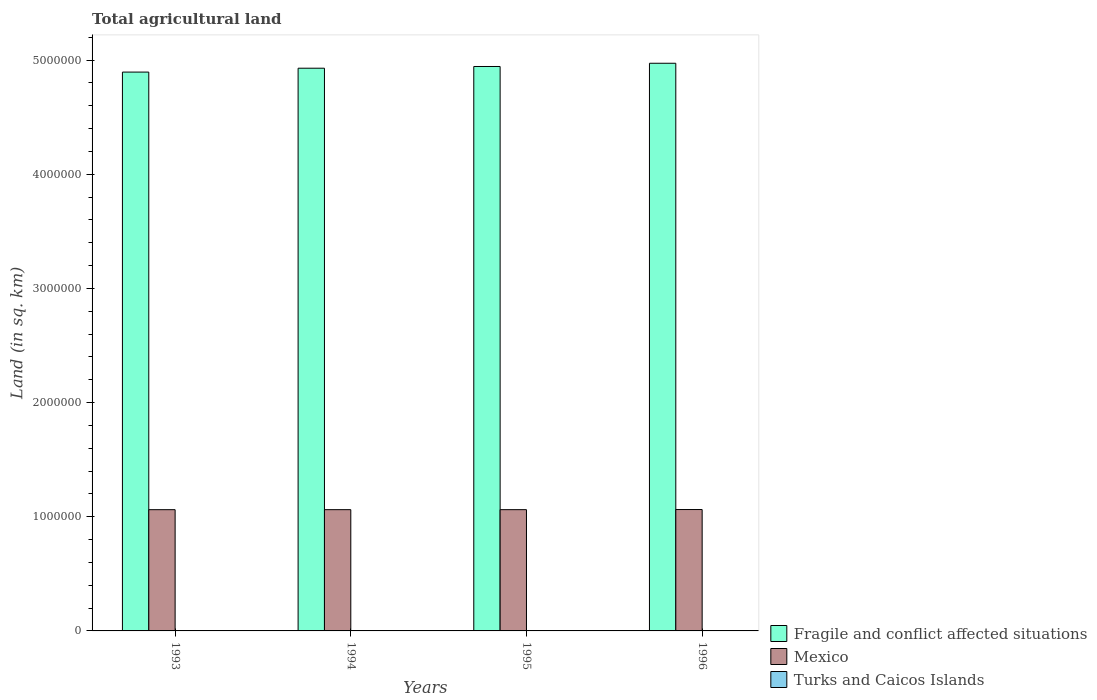How many groups of bars are there?
Make the answer very short. 4. Are the number of bars per tick equal to the number of legend labels?
Your answer should be compact. Yes. What is the label of the 2nd group of bars from the left?
Ensure brevity in your answer.  1994. What is the total agricultural land in Mexico in 1993?
Offer a very short reply. 1.06e+06. Across all years, what is the maximum total agricultural land in Turks and Caicos Islands?
Your answer should be very brief. 10. Across all years, what is the minimum total agricultural land in Mexico?
Offer a very short reply. 1.06e+06. In which year was the total agricultural land in Turks and Caicos Islands maximum?
Ensure brevity in your answer.  1993. In which year was the total agricultural land in Fragile and conflict affected situations minimum?
Your answer should be very brief. 1993. What is the total total agricultural land in Fragile and conflict affected situations in the graph?
Your answer should be compact. 1.97e+07. What is the difference between the total agricultural land in Turks and Caicos Islands in 1993 and that in 1996?
Ensure brevity in your answer.  0. What is the difference between the total agricultural land in Mexico in 1993 and the total agricultural land in Turks and Caicos Islands in 1995?
Provide a succinct answer. 1.06e+06. What is the average total agricultural land in Fragile and conflict affected situations per year?
Provide a short and direct response. 4.93e+06. In the year 1994, what is the difference between the total agricultural land in Turks and Caicos Islands and total agricultural land in Mexico?
Provide a short and direct response. -1.06e+06. In how many years, is the total agricultural land in Mexico greater than 600000 sq.km?
Your answer should be very brief. 4. What is the ratio of the total agricultural land in Mexico in 1994 to that in 1995?
Ensure brevity in your answer.  1. Is the total agricultural land in Mexico in 1993 less than that in 1994?
Give a very brief answer. Yes. What is the difference between the highest and the second highest total agricultural land in Mexico?
Provide a short and direct response. 1150. What is the difference between the highest and the lowest total agricultural land in Mexico?
Your answer should be very brief. 1300. Is the sum of the total agricultural land in Mexico in 1993 and 1996 greater than the maximum total agricultural land in Turks and Caicos Islands across all years?
Give a very brief answer. Yes. What does the 1st bar from the left in 1995 represents?
Keep it short and to the point. Fragile and conflict affected situations. What does the 3rd bar from the right in 1996 represents?
Offer a very short reply. Fragile and conflict affected situations. How many bars are there?
Offer a very short reply. 12. Are all the bars in the graph horizontal?
Your answer should be compact. No. Are the values on the major ticks of Y-axis written in scientific E-notation?
Your answer should be compact. No. Does the graph contain grids?
Make the answer very short. No. How are the legend labels stacked?
Your response must be concise. Vertical. What is the title of the graph?
Give a very brief answer. Total agricultural land. Does "Tonga" appear as one of the legend labels in the graph?
Offer a terse response. No. What is the label or title of the X-axis?
Ensure brevity in your answer.  Years. What is the label or title of the Y-axis?
Offer a very short reply. Land (in sq. km). What is the Land (in sq. km) in Fragile and conflict affected situations in 1993?
Your answer should be compact. 4.89e+06. What is the Land (in sq. km) in Mexico in 1993?
Your response must be concise. 1.06e+06. What is the Land (in sq. km) of Fragile and conflict affected situations in 1994?
Offer a terse response. 4.93e+06. What is the Land (in sq. km) in Mexico in 1994?
Make the answer very short. 1.06e+06. What is the Land (in sq. km) of Fragile and conflict affected situations in 1995?
Provide a short and direct response. 4.94e+06. What is the Land (in sq. km) in Mexico in 1995?
Keep it short and to the point. 1.06e+06. What is the Land (in sq. km) of Turks and Caicos Islands in 1995?
Offer a terse response. 10. What is the Land (in sq. km) in Fragile and conflict affected situations in 1996?
Provide a short and direct response. 4.97e+06. What is the Land (in sq. km) in Mexico in 1996?
Your answer should be very brief. 1.06e+06. What is the Land (in sq. km) of Turks and Caicos Islands in 1996?
Your answer should be compact. 10. Across all years, what is the maximum Land (in sq. km) in Fragile and conflict affected situations?
Your answer should be very brief. 4.97e+06. Across all years, what is the maximum Land (in sq. km) of Mexico?
Keep it short and to the point. 1.06e+06. Across all years, what is the minimum Land (in sq. km) of Fragile and conflict affected situations?
Offer a terse response. 4.89e+06. Across all years, what is the minimum Land (in sq. km) of Mexico?
Your answer should be very brief. 1.06e+06. What is the total Land (in sq. km) in Fragile and conflict affected situations in the graph?
Give a very brief answer. 1.97e+07. What is the total Land (in sq. km) of Mexico in the graph?
Ensure brevity in your answer.  4.25e+06. What is the total Land (in sq. km) of Turks and Caicos Islands in the graph?
Provide a succinct answer. 40. What is the difference between the Land (in sq. km) in Fragile and conflict affected situations in 1993 and that in 1994?
Ensure brevity in your answer.  -3.39e+04. What is the difference between the Land (in sq. km) in Mexico in 1993 and that in 1994?
Give a very brief answer. -100. What is the difference between the Land (in sq. km) in Turks and Caicos Islands in 1993 and that in 1994?
Provide a succinct answer. 0. What is the difference between the Land (in sq. km) in Fragile and conflict affected situations in 1993 and that in 1995?
Your answer should be compact. -4.89e+04. What is the difference between the Land (in sq. km) of Mexico in 1993 and that in 1995?
Provide a succinct answer. -150. What is the difference between the Land (in sq. km) in Fragile and conflict affected situations in 1993 and that in 1996?
Offer a very short reply. -7.73e+04. What is the difference between the Land (in sq. km) of Mexico in 1993 and that in 1996?
Provide a short and direct response. -1300. What is the difference between the Land (in sq. km) of Fragile and conflict affected situations in 1994 and that in 1995?
Your response must be concise. -1.51e+04. What is the difference between the Land (in sq. km) of Mexico in 1994 and that in 1995?
Your answer should be compact. -50. What is the difference between the Land (in sq. km) in Turks and Caicos Islands in 1994 and that in 1995?
Give a very brief answer. 0. What is the difference between the Land (in sq. km) in Fragile and conflict affected situations in 1994 and that in 1996?
Ensure brevity in your answer.  -4.34e+04. What is the difference between the Land (in sq. km) of Mexico in 1994 and that in 1996?
Give a very brief answer. -1200. What is the difference between the Land (in sq. km) in Turks and Caicos Islands in 1994 and that in 1996?
Your response must be concise. 0. What is the difference between the Land (in sq. km) of Fragile and conflict affected situations in 1995 and that in 1996?
Give a very brief answer. -2.84e+04. What is the difference between the Land (in sq. km) in Mexico in 1995 and that in 1996?
Your response must be concise. -1150. What is the difference between the Land (in sq. km) of Fragile and conflict affected situations in 1993 and the Land (in sq. km) of Mexico in 1994?
Give a very brief answer. 3.83e+06. What is the difference between the Land (in sq. km) in Fragile and conflict affected situations in 1993 and the Land (in sq. km) in Turks and Caicos Islands in 1994?
Your answer should be very brief. 4.89e+06. What is the difference between the Land (in sq. km) in Mexico in 1993 and the Land (in sq. km) in Turks and Caicos Islands in 1994?
Offer a terse response. 1.06e+06. What is the difference between the Land (in sq. km) in Fragile and conflict affected situations in 1993 and the Land (in sq. km) in Mexico in 1995?
Your answer should be very brief. 3.83e+06. What is the difference between the Land (in sq. km) of Fragile and conflict affected situations in 1993 and the Land (in sq. km) of Turks and Caicos Islands in 1995?
Ensure brevity in your answer.  4.89e+06. What is the difference between the Land (in sq. km) of Mexico in 1993 and the Land (in sq. km) of Turks and Caicos Islands in 1995?
Give a very brief answer. 1.06e+06. What is the difference between the Land (in sq. km) of Fragile and conflict affected situations in 1993 and the Land (in sq. km) of Mexico in 1996?
Provide a short and direct response. 3.83e+06. What is the difference between the Land (in sq. km) of Fragile and conflict affected situations in 1993 and the Land (in sq. km) of Turks and Caicos Islands in 1996?
Offer a terse response. 4.89e+06. What is the difference between the Land (in sq. km) of Mexico in 1993 and the Land (in sq. km) of Turks and Caicos Islands in 1996?
Offer a terse response. 1.06e+06. What is the difference between the Land (in sq. km) in Fragile and conflict affected situations in 1994 and the Land (in sq. km) in Mexico in 1995?
Provide a succinct answer. 3.87e+06. What is the difference between the Land (in sq. km) in Fragile and conflict affected situations in 1994 and the Land (in sq. km) in Turks and Caicos Islands in 1995?
Provide a succinct answer. 4.93e+06. What is the difference between the Land (in sq. km) in Mexico in 1994 and the Land (in sq. km) in Turks and Caicos Islands in 1995?
Your answer should be very brief. 1.06e+06. What is the difference between the Land (in sq. km) in Fragile and conflict affected situations in 1994 and the Land (in sq. km) in Mexico in 1996?
Give a very brief answer. 3.87e+06. What is the difference between the Land (in sq. km) of Fragile and conflict affected situations in 1994 and the Land (in sq. km) of Turks and Caicos Islands in 1996?
Ensure brevity in your answer.  4.93e+06. What is the difference between the Land (in sq. km) of Mexico in 1994 and the Land (in sq. km) of Turks and Caicos Islands in 1996?
Ensure brevity in your answer.  1.06e+06. What is the difference between the Land (in sq. km) in Fragile and conflict affected situations in 1995 and the Land (in sq. km) in Mexico in 1996?
Keep it short and to the point. 3.88e+06. What is the difference between the Land (in sq. km) of Fragile and conflict affected situations in 1995 and the Land (in sq. km) of Turks and Caicos Islands in 1996?
Your answer should be very brief. 4.94e+06. What is the difference between the Land (in sq. km) of Mexico in 1995 and the Land (in sq. km) of Turks and Caicos Islands in 1996?
Offer a terse response. 1.06e+06. What is the average Land (in sq. km) of Fragile and conflict affected situations per year?
Offer a very short reply. 4.93e+06. What is the average Land (in sq. km) of Mexico per year?
Make the answer very short. 1.06e+06. What is the average Land (in sq. km) of Turks and Caicos Islands per year?
Your answer should be compact. 10. In the year 1993, what is the difference between the Land (in sq. km) in Fragile and conflict affected situations and Land (in sq. km) in Mexico?
Make the answer very short. 3.83e+06. In the year 1993, what is the difference between the Land (in sq. km) in Fragile and conflict affected situations and Land (in sq. km) in Turks and Caicos Islands?
Your answer should be compact. 4.89e+06. In the year 1993, what is the difference between the Land (in sq. km) of Mexico and Land (in sq. km) of Turks and Caicos Islands?
Provide a succinct answer. 1.06e+06. In the year 1994, what is the difference between the Land (in sq. km) of Fragile and conflict affected situations and Land (in sq. km) of Mexico?
Ensure brevity in your answer.  3.87e+06. In the year 1994, what is the difference between the Land (in sq. km) in Fragile and conflict affected situations and Land (in sq. km) in Turks and Caicos Islands?
Your answer should be very brief. 4.93e+06. In the year 1994, what is the difference between the Land (in sq. km) in Mexico and Land (in sq. km) in Turks and Caicos Islands?
Give a very brief answer. 1.06e+06. In the year 1995, what is the difference between the Land (in sq. km) of Fragile and conflict affected situations and Land (in sq. km) of Mexico?
Your answer should be compact. 3.88e+06. In the year 1995, what is the difference between the Land (in sq. km) in Fragile and conflict affected situations and Land (in sq. km) in Turks and Caicos Islands?
Provide a succinct answer. 4.94e+06. In the year 1995, what is the difference between the Land (in sq. km) of Mexico and Land (in sq. km) of Turks and Caicos Islands?
Offer a terse response. 1.06e+06. In the year 1996, what is the difference between the Land (in sq. km) in Fragile and conflict affected situations and Land (in sq. km) in Mexico?
Provide a succinct answer. 3.91e+06. In the year 1996, what is the difference between the Land (in sq. km) of Fragile and conflict affected situations and Land (in sq. km) of Turks and Caicos Islands?
Your response must be concise. 4.97e+06. In the year 1996, what is the difference between the Land (in sq. km) in Mexico and Land (in sq. km) in Turks and Caicos Islands?
Keep it short and to the point. 1.06e+06. What is the ratio of the Land (in sq. km) in Mexico in 1993 to that in 1994?
Provide a succinct answer. 1. What is the ratio of the Land (in sq. km) of Turks and Caicos Islands in 1993 to that in 1995?
Your answer should be compact. 1. What is the ratio of the Land (in sq. km) of Fragile and conflict affected situations in 1993 to that in 1996?
Ensure brevity in your answer.  0.98. What is the ratio of the Land (in sq. km) of Mexico in 1994 to that in 1995?
Ensure brevity in your answer.  1. What is the ratio of the Land (in sq. km) in Mexico in 1994 to that in 1996?
Your answer should be very brief. 1. What is the ratio of the Land (in sq. km) of Mexico in 1995 to that in 1996?
Your answer should be compact. 1. What is the ratio of the Land (in sq. km) in Turks and Caicos Islands in 1995 to that in 1996?
Offer a very short reply. 1. What is the difference between the highest and the second highest Land (in sq. km) of Fragile and conflict affected situations?
Ensure brevity in your answer.  2.84e+04. What is the difference between the highest and the second highest Land (in sq. km) in Mexico?
Your response must be concise. 1150. What is the difference between the highest and the second highest Land (in sq. km) of Turks and Caicos Islands?
Offer a very short reply. 0. What is the difference between the highest and the lowest Land (in sq. km) of Fragile and conflict affected situations?
Offer a very short reply. 7.73e+04. What is the difference between the highest and the lowest Land (in sq. km) of Mexico?
Give a very brief answer. 1300. What is the difference between the highest and the lowest Land (in sq. km) of Turks and Caicos Islands?
Give a very brief answer. 0. 